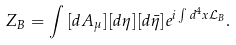Convert formula to latex. <formula><loc_0><loc_0><loc_500><loc_500>Z _ { B } = \int { [ d A _ { \mu } ] } { [ d \eta ] } { [ d \bar { \eta } ] } e ^ { i \int d ^ { 4 } x { \mathcal { L } } _ { B } } .</formula> 